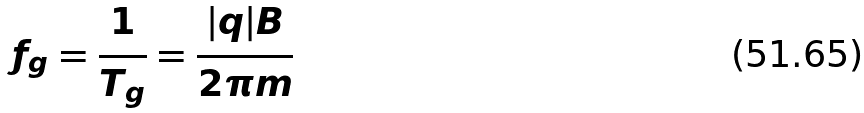Convert formula to latex. <formula><loc_0><loc_0><loc_500><loc_500>f _ { g } = \frac { 1 } { T _ { g } } = \frac { | q | B } { 2 \pi m }</formula> 